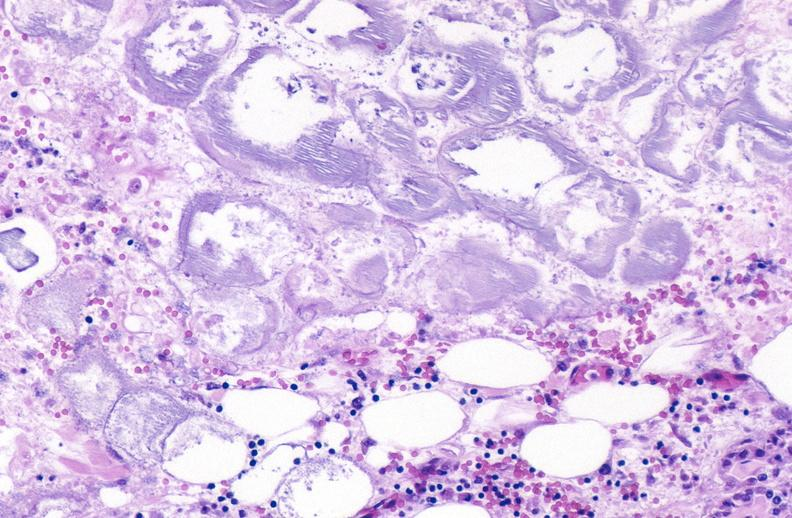does this image show pancreatic fat necrosis?
Answer the question using a single word or phrase. Yes 